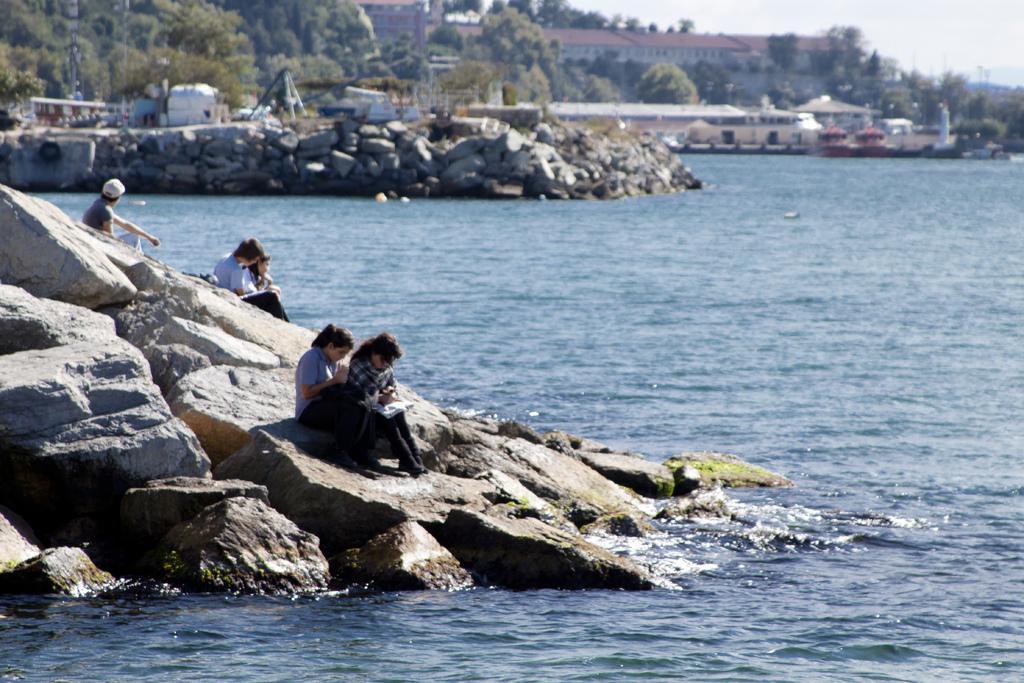How would you summarize this image in a sentence or two? In this picture there are people on the rocks, on the left side of the image and there is water on the right side of the image and there are ships in the top right side of the image, there are trees and buildings in the background area of the image. 